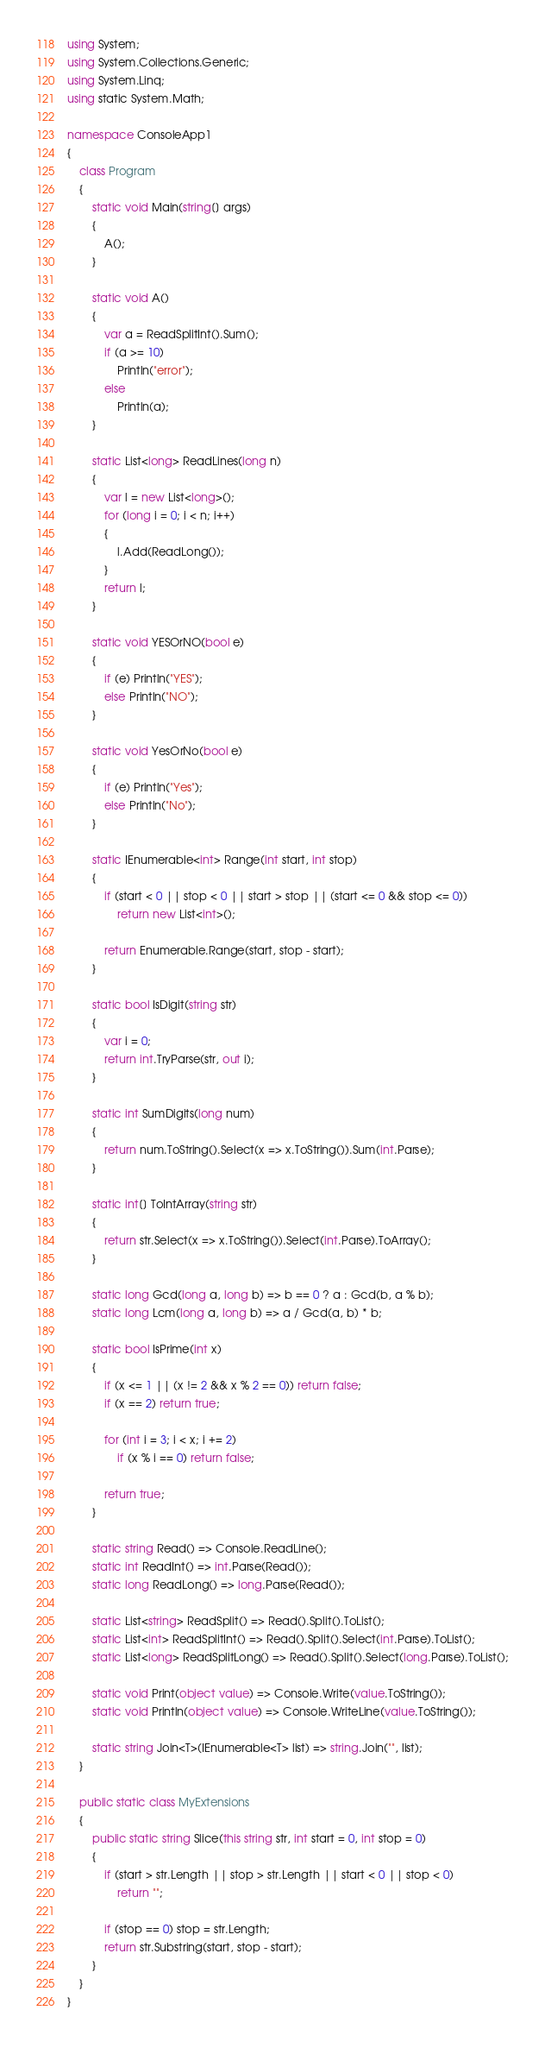Convert code to text. <code><loc_0><loc_0><loc_500><loc_500><_C#_>using System;
using System.Collections.Generic;
using System.Linq;
using static System.Math;

namespace ConsoleApp1
{
    class Program
    {
        static void Main(string[] args)
        {
            A();
        }

        static void A()
        {
            var a = ReadSplitInt().Sum();
            if (a >= 10)
                Println("error");
            else
                Println(a);
        }

        static List<long> ReadLines(long n)
        {
            var l = new List<long>();
            for (long i = 0; i < n; i++)
            {
                l.Add(ReadLong());
            }
            return l;
        }

        static void YESOrNO(bool e)
        {
            if (e) Println("YES");
            else Println("NO");
        }

        static void YesOrNo(bool e)
        {
            if (e) Println("Yes");
            else Println("No");
        }

        static IEnumerable<int> Range(int start, int stop)
        {
            if (start < 0 || stop < 0 || start > stop || (start <= 0 && stop <= 0))
                return new List<int>();

            return Enumerable.Range(start, stop - start);
        }

        static bool IsDigit(string str)
        {
            var i = 0;
            return int.TryParse(str, out i);
        }

        static int SumDigits(long num)
        {
            return num.ToString().Select(x => x.ToString()).Sum(int.Parse);
        }

        static int[] ToIntArray(string str)
        {
            return str.Select(x => x.ToString()).Select(int.Parse).ToArray();
        }

        static long Gcd(long a, long b) => b == 0 ? a : Gcd(b, a % b);
        static long Lcm(long a, long b) => a / Gcd(a, b) * b;

        static bool IsPrime(int x)
        {
            if (x <= 1 || (x != 2 && x % 2 == 0)) return false;
            if (x == 2) return true;

            for (int i = 3; i < x; i += 2)
                if (x % i == 0) return false;

            return true;
        }

        static string Read() => Console.ReadLine();
        static int ReadInt() => int.Parse(Read());
        static long ReadLong() => long.Parse(Read());

        static List<string> ReadSplit() => Read().Split().ToList();
        static List<int> ReadSplitInt() => Read().Split().Select(int.Parse).ToList();
        static List<long> ReadSplitLong() => Read().Split().Select(long.Parse).ToList();

        static void Print(object value) => Console.Write(value.ToString());
        static void Println(object value) => Console.WriteLine(value.ToString());

        static string Join<T>(IEnumerable<T> list) => string.Join("", list);
    }

    public static class MyExtensions
    {
        public static string Slice(this string str, int start = 0, int stop = 0)
        {
            if (start > str.Length || stop > str.Length || start < 0 || stop < 0)
                return "";

            if (stop == 0) stop = str.Length;
            return str.Substring(start, stop - start);
        }
    }
}
</code> 